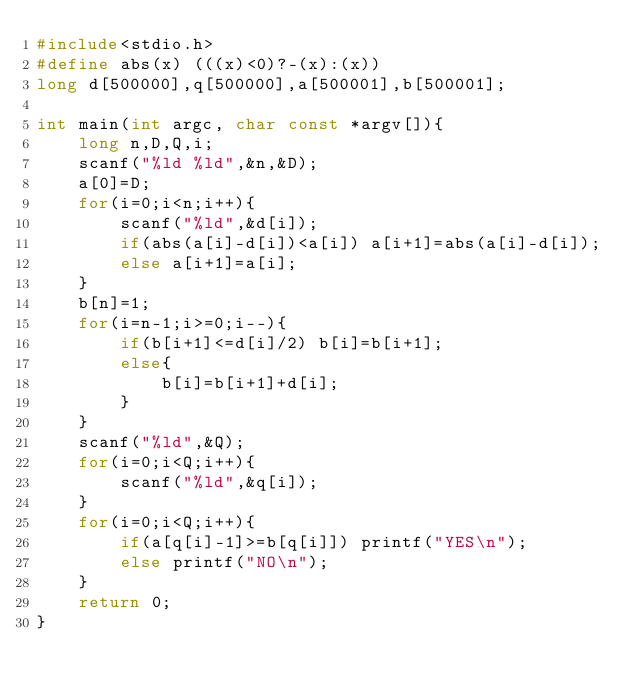Convert code to text. <code><loc_0><loc_0><loc_500><loc_500><_C_>#include<stdio.h>
#define abs(x) (((x)<0)?-(x):(x))
long d[500000],q[500000],a[500001],b[500001];

int main(int argc, char const *argv[]){
	long n,D,Q,i;
	scanf("%ld %ld",&n,&D);
	a[0]=D;
	for(i=0;i<n;i++){
		scanf("%ld",&d[i]);
		if(abs(a[i]-d[i])<a[i]) a[i+1]=abs(a[i]-d[i]);
		else a[i+1]=a[i];
	}
	b[n]=1;
	for(i=n-1;i>=0;i--){
		if(b[i+1]<=d[i]/2) b[i]=b[i+1];
		else{
			b[i]=b[i+1]+d[i];
		}
	}
	scanf("%ld",&Q);
	for(i=0;i<Q;i++){
		scanf("%ld",&q[i]);
	}
	for(i=0;i<Q;i++){
		if(a[q[i]-1]>=b[q[i]]) printf("YES\n");
		else printf("NO\n");
	}
	return 0;
}</code> 